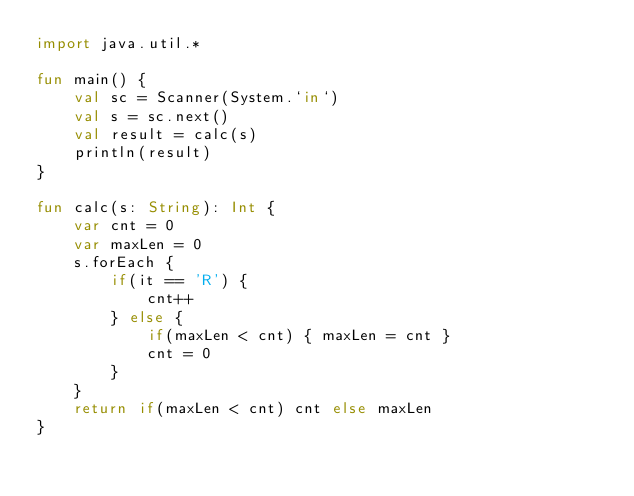<code> <loc_0><loc_0><loc_500><loc_500><_Kotlin_>import java.util.*

fun main() {
    val sc = Scanner(System.`in`)
    val s = sc.next()
    val result = calc(s)
    println(result)
}

fun calc(s: String): Int {
    var cnt = 0
    var maxLen = 0
    s.forEach {
        if(it == 'R') {
            cnt++
        } else {
            if(maxLen < cnt) { maxLen = cnt }
            cnt = 0
        }
    }
    return if(maxLen < cnt) cnt else maxLen
}
</code> 